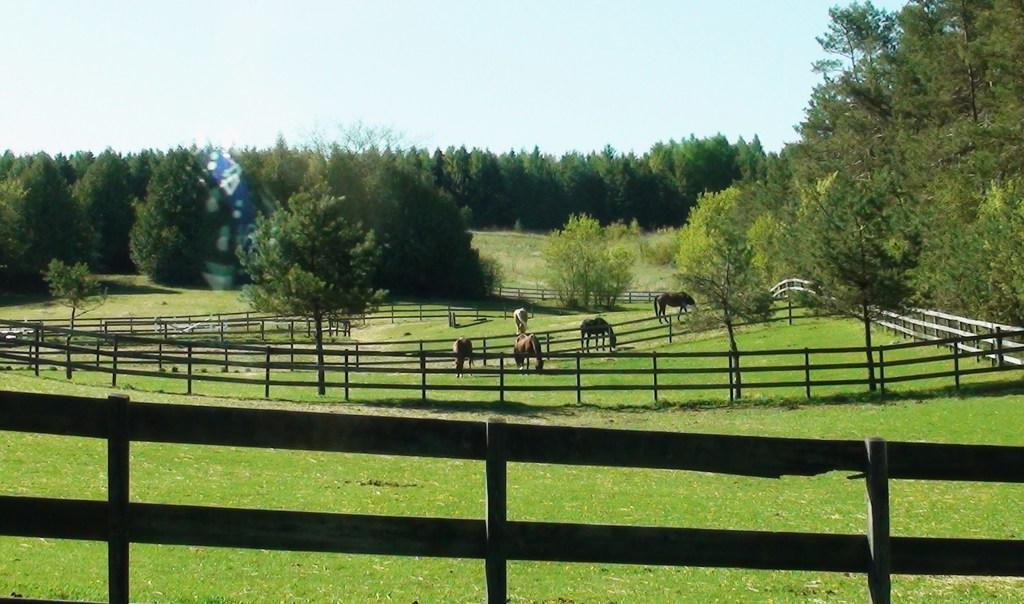What type of living organisms can be seen in the image? There are animals in the image. Where are the animals located? The animals are on the grass. What is surrounding the grass in the image? There is fencing around the grass. What can be seen in the background of the image? Trees are visible in the background of the image. What type of peace is being practiced by the animals in the image? There is no indication in the image that the animals are practicing any type of peace. 